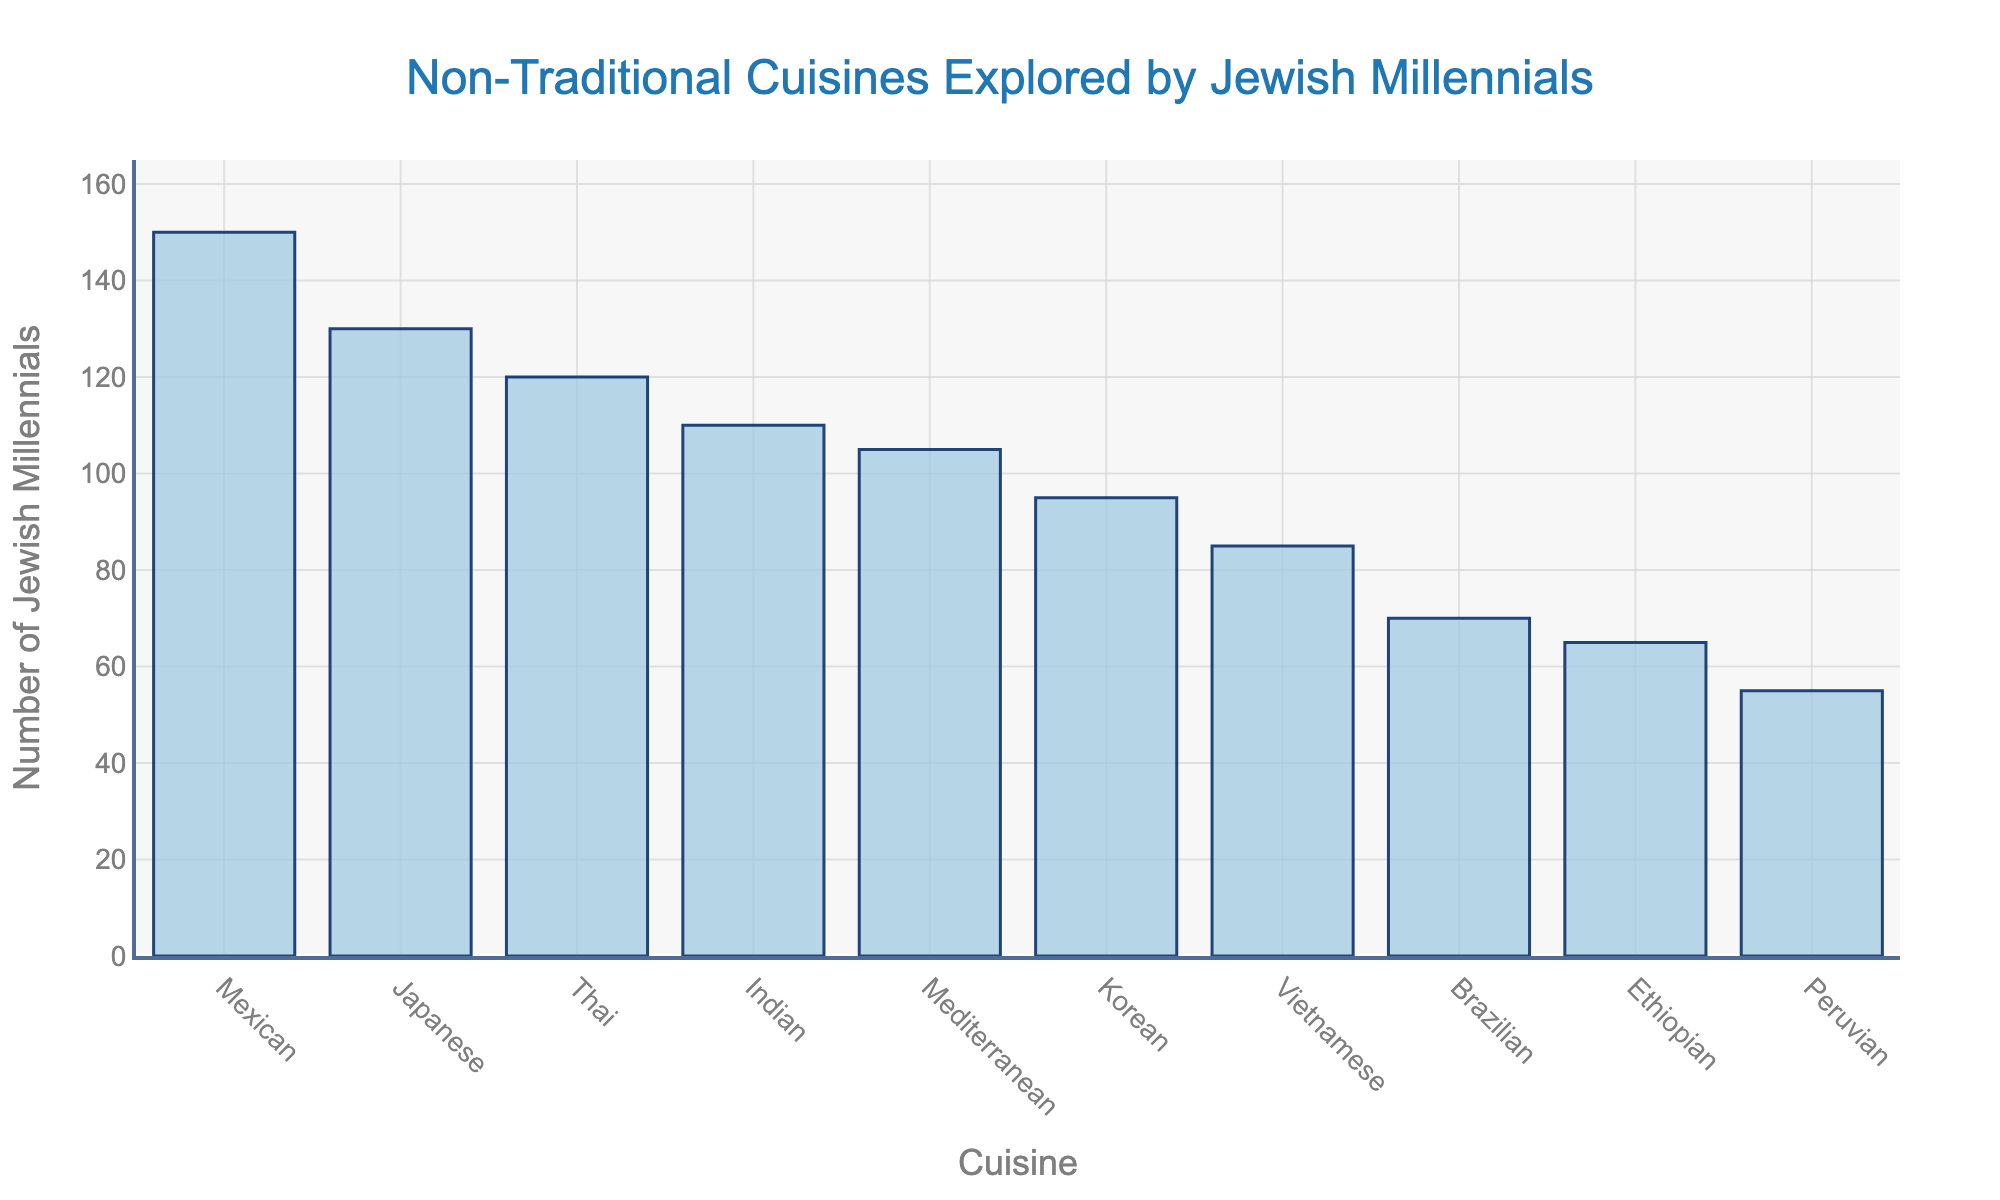Which cuisine has the highest number of Jewish millennials trying it? By looking at the histogram, the bar that represents Mexican cuisine is the tallest, indicating it has the highest number of Jewish millennials who have tried it.
Answer: Mexican Which cuisine has been tried by the least number of Jewish millennials? The shortest bar in the histogram represents Peruvian cuisine, meaning it has been tried by the least number of Jewish millennials.
Answer: Peruvian What is the difference in the number of Jewish millennials who tried Mexican and Ethiopian cuisines? The bar for Mexican cuisine shows 150, and the bar for Ethiopian cuisine shows 65. Subtracting these values gives 150 - 65 = 85.
Answer: 85 How many more Jewish millennials tried Japanese cuisine compared to Korean cuisine? According to the figure, 130 Jewish millennials tried Japanese cuisine and 95 tried Korean cuisine. Calculating the difference yields 130 - 95 = 35.
Answer: 35 What is the total number of Jewish millennials who tried Vietnamese and Mediterranean cuisines combined? The figure shows that 85 Jewish millennials tried Vietnamese cuisine and 105 tried Mediterranean cuisine. Adding these numbers gives 85 + 105 = 190.
Answer: 190 What is the average number of Jewish millennials who tried Ethiopian, Brazilian, and Peruvian cuisines? The values for Ethiopian, Brazilian, and Peruvian cuisines are 65, 70, and 55 respectively. Summing these values gives 65 + 70 + 55 = 190. Dividing by 3 gives 190 / 3 ≈ 63.33.
Answer: Approximately 63.33 Which cuisines have been tried by more than 100 Jewish millennials? The bars for Thai, Japanese, Indian, Mexican, and Mediterranean cuisines all extend past the 100 mark on the y-axis, indicating that more than 100 Jewish millennials tried these cuisines.
Answer: Thai, Japanese, Indian, Mexican, Mediterranean How many cuisines have been tried by at least 95 Jewish millennials? By counting the bars which extend to at least the 95 mark on the y-axis, which includes Korean, Thai, Vietnamese, Japanese, Indian, Mexican, and Mediterranean, we find there are 7 such cuisines.
Answer: 7 Are there more Jewish millennials who tried Brazilian or Ethiopian cuisine? Comparing the bars, the Brazilian cuisine bar is taller than the Ethiopian cuisine bar, indicating more Jewish millennials tried Brazilian cuisine.
Answer: Brazilian What is the median number of Jewish millennials trying these cuisines? Listing the values in ascending order: 55, 65, 70, 85, 95, 105, 110, 120, 130, 150. The median is the middle value, so for 10 data points, it would be the average of the 5th and 6th values: (95+105)/2 = 100.
Answer: 100 